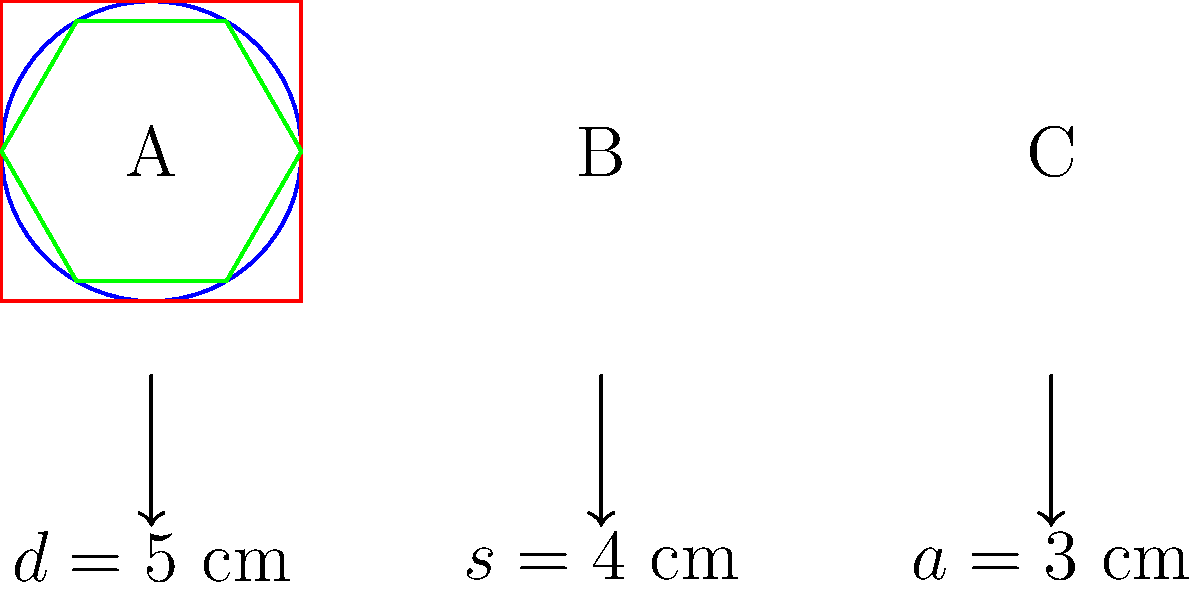As a cosmetics CEO focusing on traditional packaging, you're evaluating three compact powder case designs: circular (A), square (B), and hexagonal (C). Given that the circular case has a diameter of 5 cm, the square case has a side length of 4 cm, and the hexagonal case has an apothem of 3 cm, calculate the total surface area (top and bottom) for each design. Which design requires the least amount of material for packaging? Let's calculate the surface area for each design:

A. Circular case:
   Area of a circle = $\pi r^2$
   Diameter = 5 cm, so radius = 2.5 cm
   Surface area = $2 \pi r^2 = 2 \pi (2.5)^2 = 39.27$ cm²

B. Square case:
   Area of a square = $s^2$
   Side length = 4 cm
   Surface area = $2s^2 = 2(4)^2 = 32$ cm²

C. Hexagonal case:
   Area of a regular hexagon = $\frac{3\sqrt{3}}{2}a^2$, where $a$ is the side length
   Apothem = 3 cm
   Side length = $\frac{2a}{\sqrt{3}} = \frac{2(3)}{\sqrt{3}} = 3.46$ cm
   Surface area = $2 \cdot \frac{3\sqrt{3}}{2}(3.46)^2 = 62.35$ cm²

Comparing the surface areas:
Square (32 cm²) < Circle (39.27 cm²) < Hexagon (62.35 cm²)

The square design requires the least amount of material for packaging.
Answer: Square design; 32 cm² 